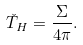Convert formula to latex. <formula><loc_0><loc_0><loc_500><loc_500>\check { T } _ { H } = \frac { \Sigma } { 4 \pi } .</formula> 